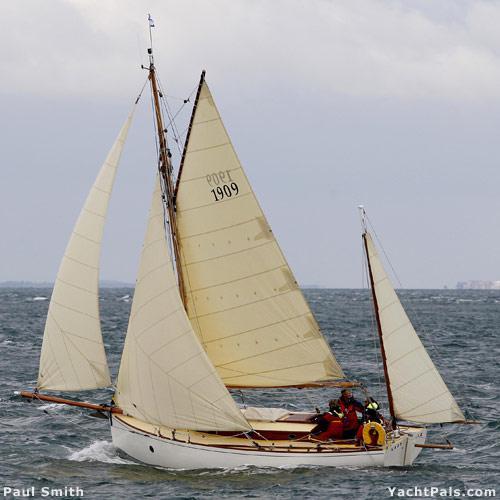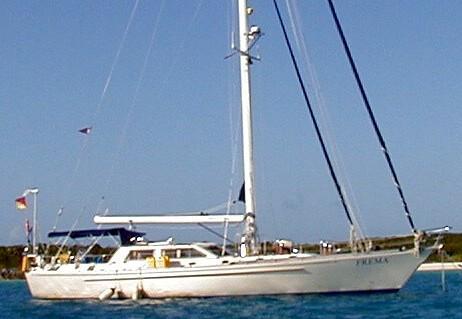The first image is the image on the left, the second image is the image on the right. Assess this claim about the two images: "One of the boats has all its sails furled and is aimed toward the right.". Correct or not? Answer yes or no. Yes. The first image is the image on the left, the second image is the image on the right. Examine the images to the left and right. Is the description "One of the images features a sailboat with its sails furled" accurate? Answer yes or no. Yes. 